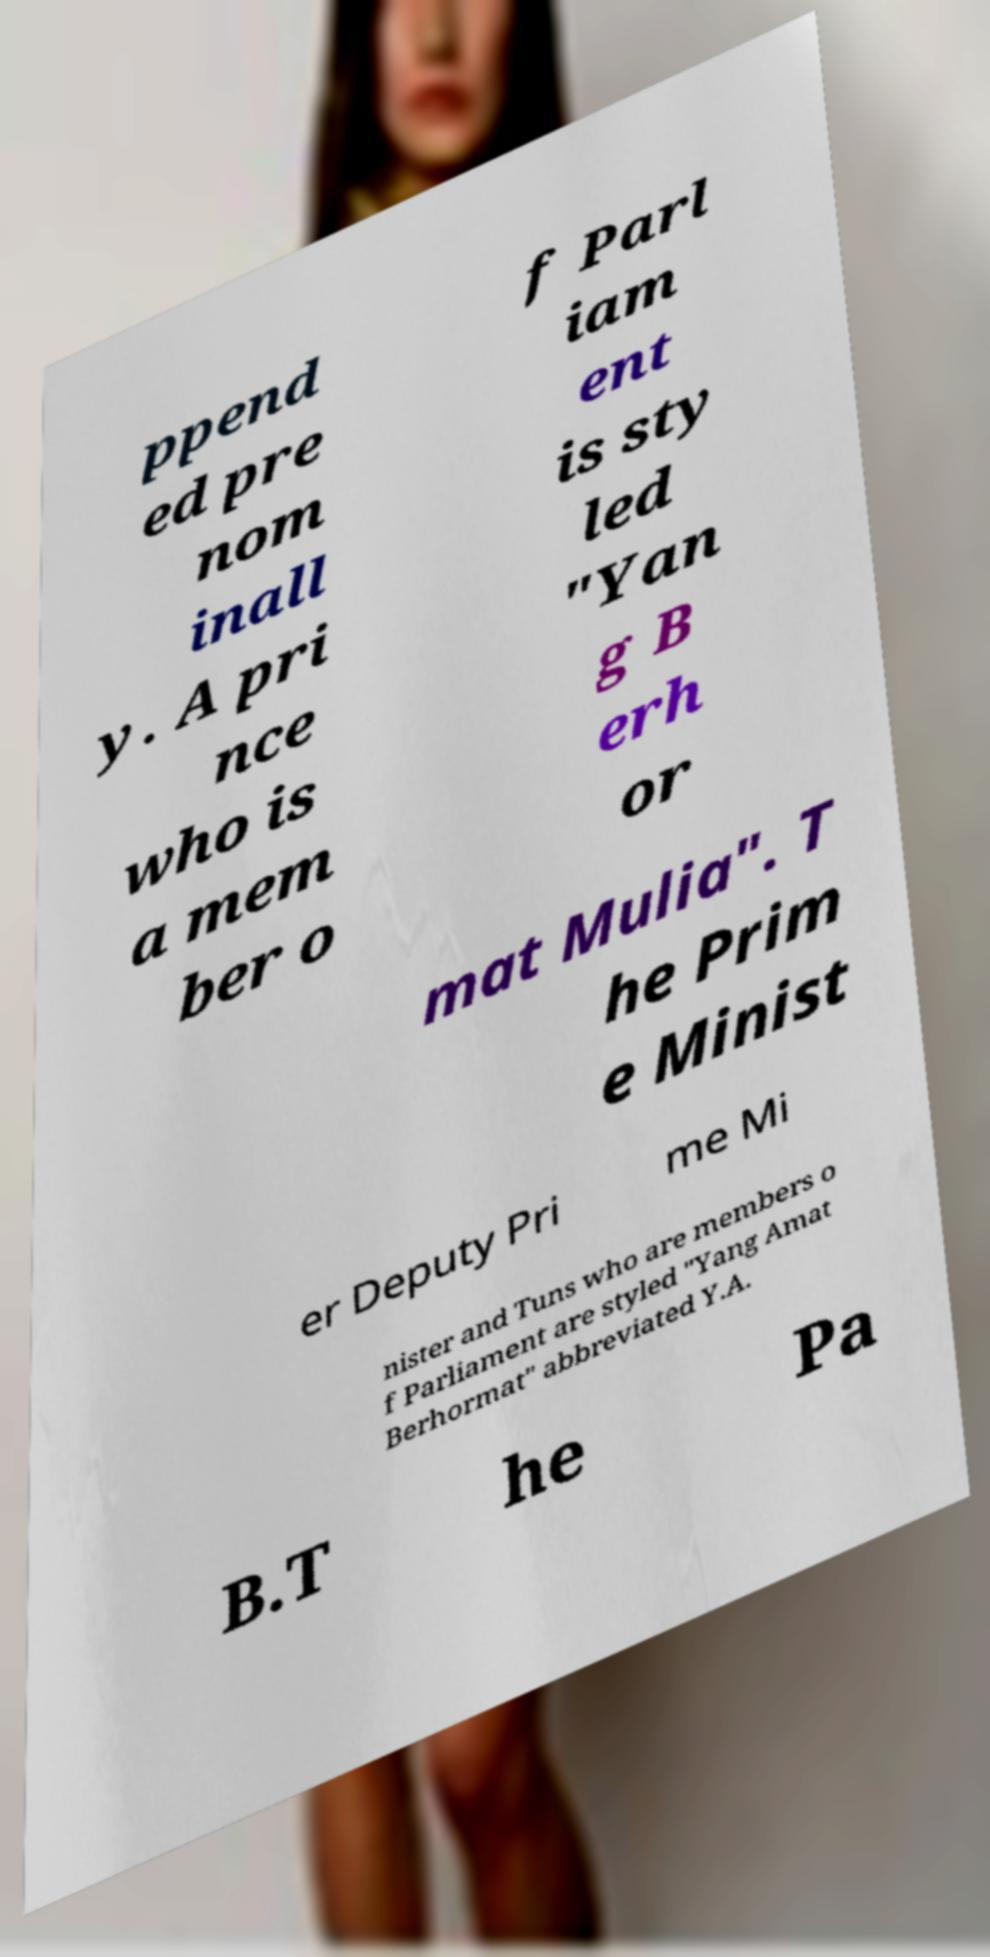What messages or text are displayed in this image? I need them in a readable, typed format. ppend ed pre nom inall y. A pri nce who is a mem ber o f Parl iam ent is sty led "Yan g B erh or mat Mulia". T he Prim e Minist er Deputy Pri me Mi nister and Tuns who are members o f Parliament are styled "Yang Amat Berhormat" abbreviated Y.A. B.T he Pa 